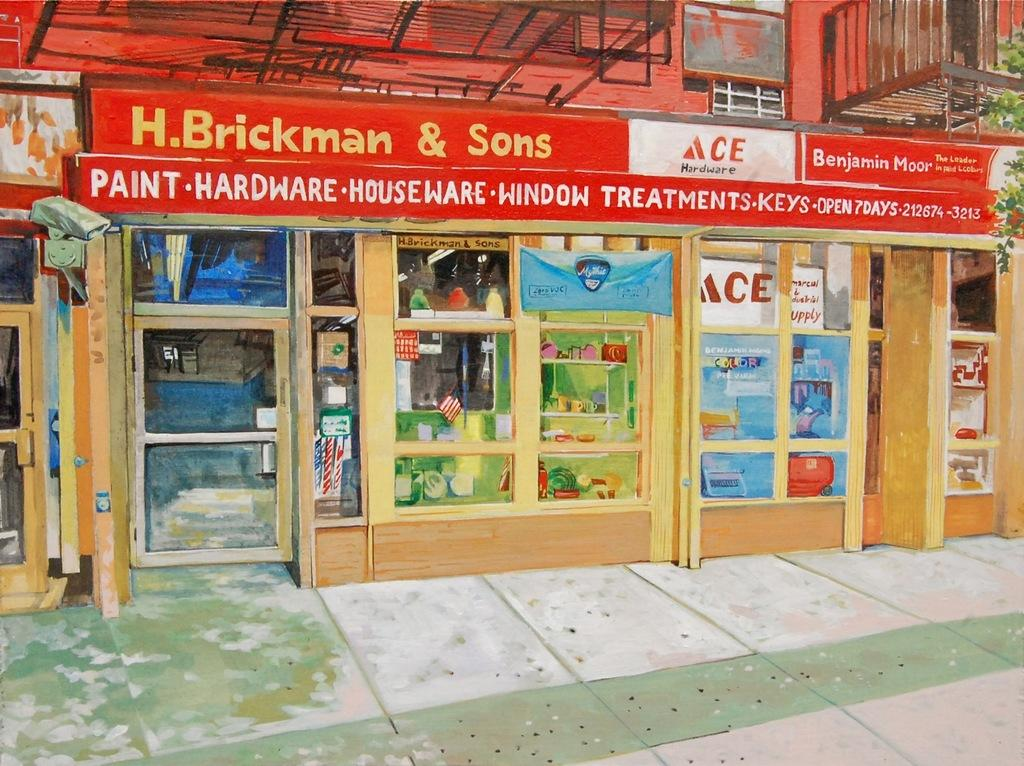<image>
Provide a brief description of the given image. A painting of an H. Brickman & Sons Ace Hardware store. 